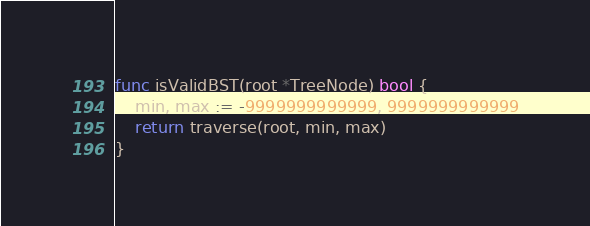Convert code to text. <code><loc_0><loc_0><loc_500><loc_500><_Go_>
func isValidBST(root *TreeNode) bool {
	min, max := -9999999999999, 9999999999999
	return traverse(root, min, max)
}
</code> 